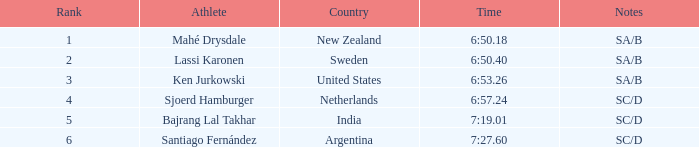What is listed in notes for the athlete, lassi karonen? SA/B. Could you parse the entire table? {'header': ['Rank', 'Athlete', 'Country', 'Time', 'Notes'], 'rows': [['1', 'Mahé Drysdale', 'New Zealand', '6:50.18', 'SA/B'], ['2', 'Lassi Karonen', 'Sweden', '6:50.40', 'SA/B'], ['3', 'Ken Jurkowski', 'United States', '6:53.26', 'SA/B'], ['4', 'Sjoerd Hamburger', 'Netherlands', '6:57.24', 'SC/D'], ['5', 'Bajrang Lal Takhar', 'India', '7:19.01', 'SC/D'], ['6', 'Santiago Fernández', 'Argentina', '7:27.60', 'SC/D']]} 